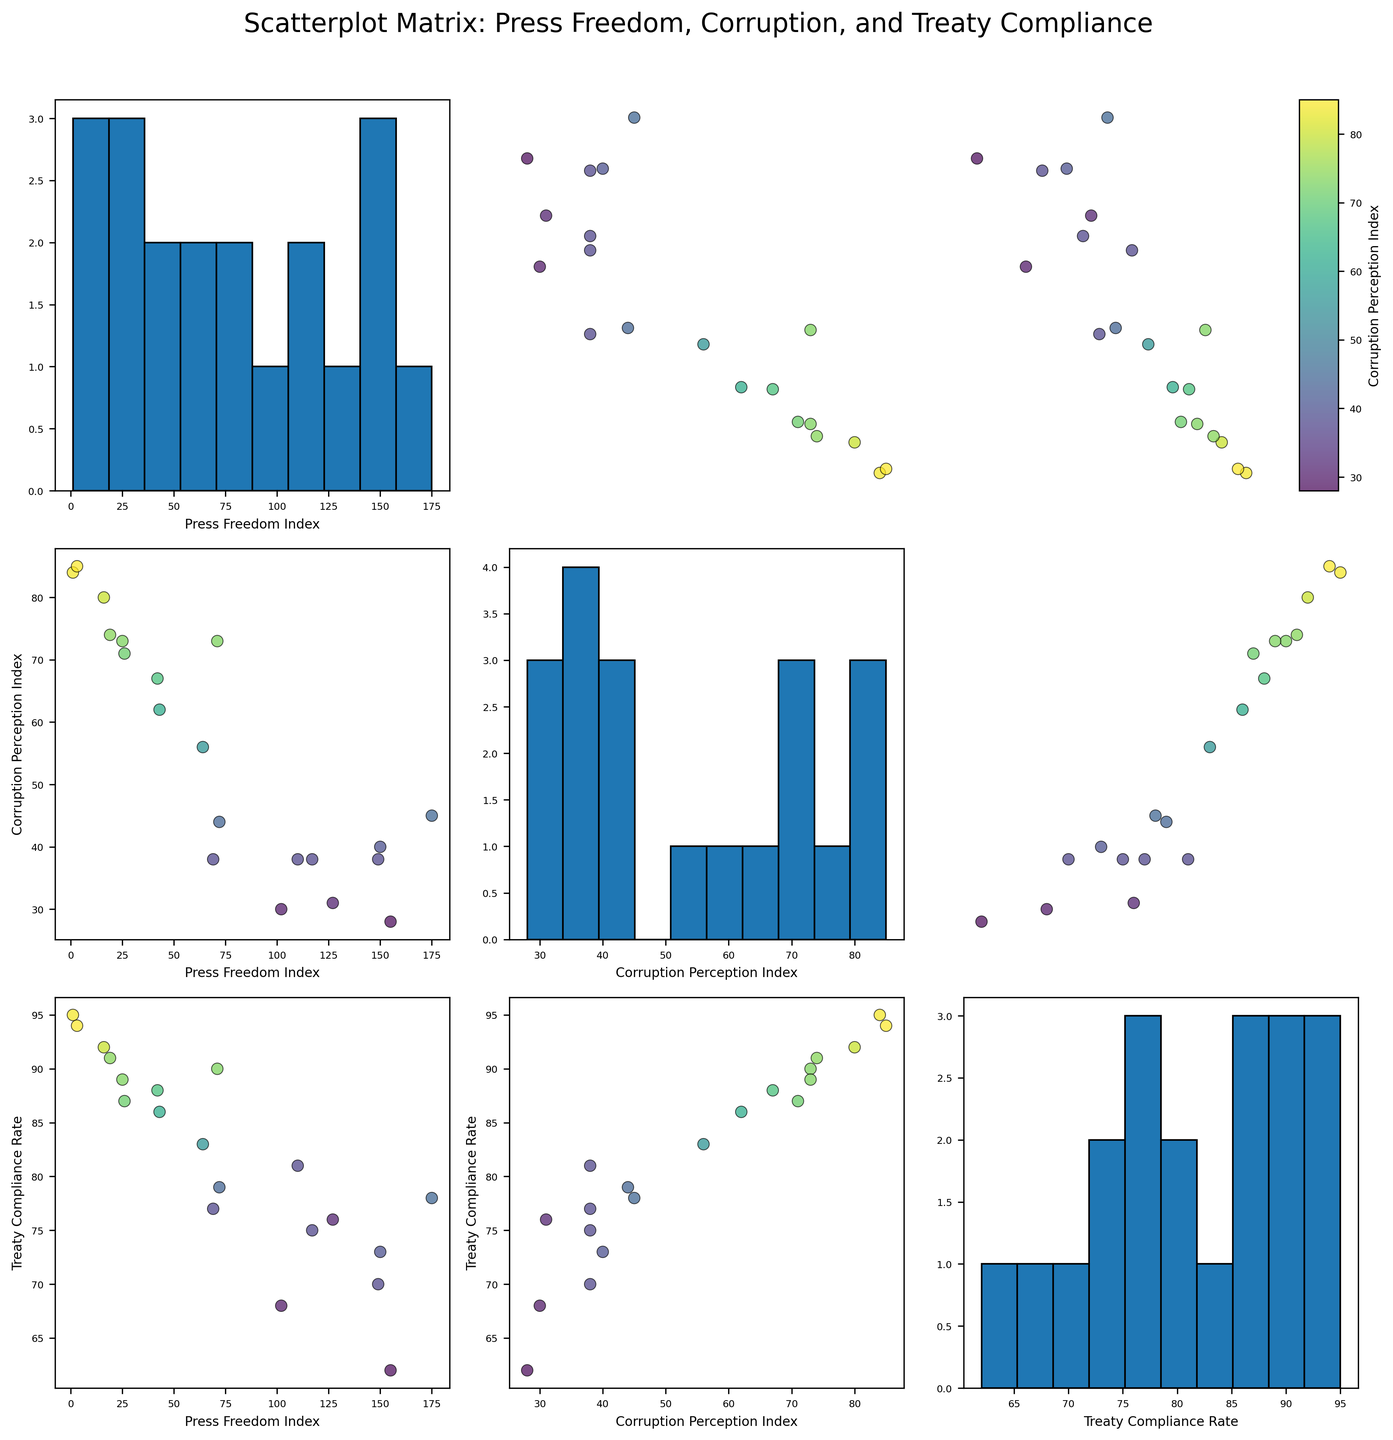What is the title of the figure? The title is located at the top of the figure and is usually the first element you see that describes the overall content of the plot.
Answer: Scatterplot Matrix: Press Freedom, Corruption, and Treaty Compliance How many variables are being compared in the scatterplot matrix? In a scatterplot matrix, each variable is compared against every other variable, including itself along the diagonals. By counting the unique variable labels shared across the rows and columns, we observe that three variables are compared.
Answer: Three variables How is the Corruption Perception Index represented within the scatterplots? In scatterplot matrices, additional dimensions of data can sometimes be represented by color, size, or shape. Here, the points' colors in the scatterplots signify the Corruption Perception Index, indicated by a color bar.
Answer: By color Which country has the highest Press Freedom Index and what is its corresponding Treaty Compliance Rate? To identify the highest Press Freedom Index, look for the smallest numerical value in the Press Freedom histograms (since it's ranked inversely). Norway has the highest Press Freedom Index (value of 1) with a Treaty Compliance Rate of 95.
Answer: Norway, 95 Is there a visible correlation between Corruption Perception Index and Treaty Compliance Rate? Examine the scatterplot where the axes are labeled with Corruption Perception Index and Treaty Compliance Rate. Look for a trend: an upward trend implies positive correlation, while a downward trend implies negative correlation. There appears to be a weak positive correlation, as higher Corruption Perception Index values typically align with higher Treaty Compliance Rates.
Answer: Weak positive correlation Which country appears to have the lowest Corruption Perception Index and what is its Press Freedom Index? To find the lowest Corruption Perception Index, find the darkest color point in any of the scatterplots. Russia, represented by the darkest shade, has the lowest Corruption Perception Index of 28 and a Press Freedom Index of 155.
Answer: Russia, 155 Do countries with high Treaty Compliance Rates generally have low Corruption Perception Indexes? Examine the scatterplot labeled with Treaty Compliance Rate and Corruption Perception Index. Visual correlation can be seen by identifying if high Treaty Compliance Rates align with lower Corruption Perception Index values. Generally, countries with higher treaty compliance rates seem to have higher Corruption Perception Indexes (which implies lower corruption).
Answer: Generally not Compare the Press Freedom Index of the United States and China. Which country has a better (lower) Press Freedom Index? Locate the Press Freedom Index values for both the United States (42) and China (175) in the scatterplot where both these countries appear. Comparatively, the United States has a lower and thus better Press Freedom Index than China.
Answer: United States Is there a noticeable relationship between Press Freedom Index and Treaty Compliance Rate? Inspect the scatterplot with the axes Press Freedom Index and Treaty Compliance Rate for any noticeable trend. Points scattered without a distinct pattern indicate a weak or no correlation, while an identifiable trend line indicates a relationship. There appears to be no noticeable correlation between these two variables.
Answer: No noticeable correlation What is the general distribution of the Corruption Perception Index among the countries plotted? Check the histogram labeled with the Corruption Perception Index to assess how the values are distributed across bins. This can show whether the values are clustered in a specific range or more evenly distributed. The distribution shows a concentration around the mid-range values, indicating most countries fall between moderate levels of perceivable corruption.
Answer: Mid-range clustered distribution 